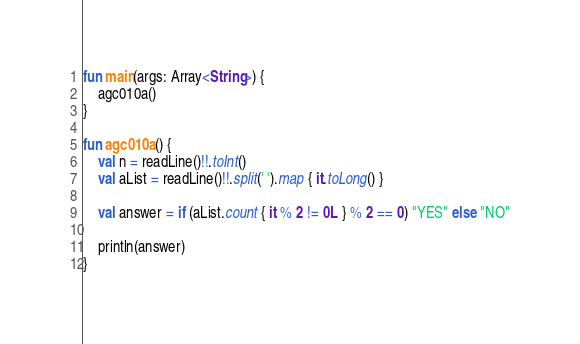<code> <loc_0><loc_0><loc_500><loc_500><_Kotlin_>fun main(args: Array<String>) {
    agc010a()
}

fun agc010a() {
    val n = readLine()!!.toInt()
    val aList = readLine()!!.split(' ').map { it.toLong() }

    val answer = if (aList.count { it % 2 != 0L } % 2 == 0) "YES" else "NO"

    println(answer)
}
</code> 